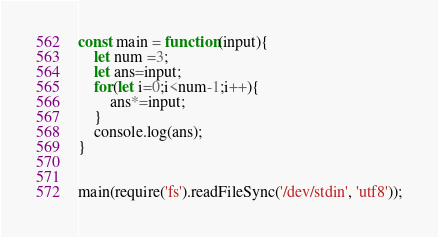<code> <loc_0><loc_0><loc_500><loc_500><_JavaScript_>const main = function(input){
    let num =3;
    let ans=input;
    for(let i=0;i<num-1;i++){
        ans*=input;
    }
    console.log(ans);
}


main(require('fs').readFileSync('/dev/stdin', 'utf8'));
</code> 